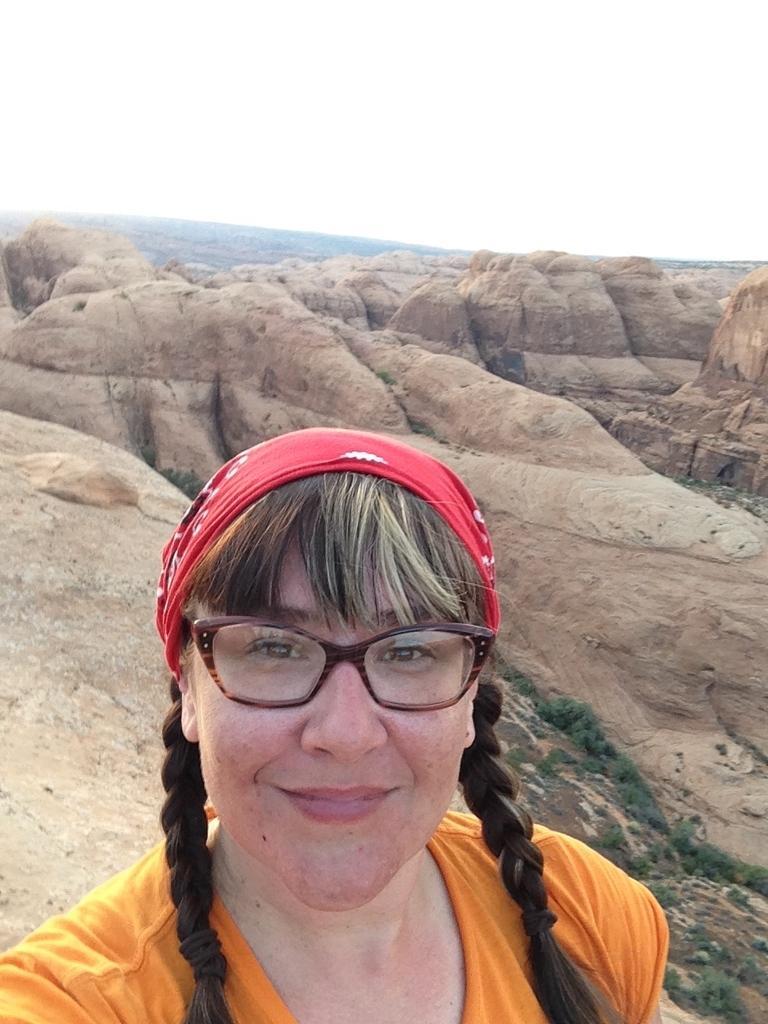How would you summarize this image in a sentence or two? In this picture I can see a woman with spectacles. I can see rocks, and in the background there is the sky. 